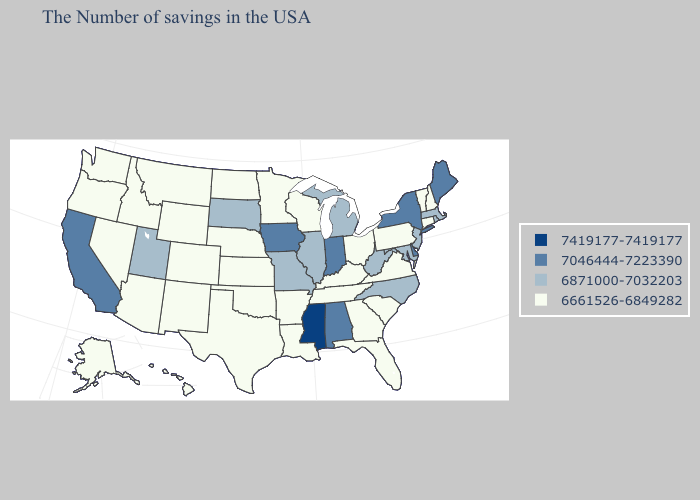What is the highest value in states that border Wyoming?
Be succinct. 6871000-7032203. Among the states that border Rhode Island , does Massachusetts have the lowest value?
Answer briefly. No. Name the states that have a value in the range 6661526-6849282?
Be succinct. New Hampshire, Vermont, Connecticut, Pennsylvania, Virginia, South Carolina, Ohio, Florida, Georgia, Kentucky, Tennessee, Wisconsin, Louisiana, Arkansas, Minnesota, Kansas, Nebraska, Oklahoma, Texas, North Dakota, Wyoming, Colorado, New Mexico, Montana, Arizona, Idaho, Nevada, Washington, Oregon, Alaska, Hawaii. Name the states that have a value in the range 6661526-6849282?
Keep it brief. New Hampshire, Vermont, Connecticut, Pennsylvania, Virginia, South Carolina, Ohio, Florida, Georgia, Kentucky, Tennessee, Wisconsin, Louisiana, Arkansas, Minnesota, Kansas, Nebraska, Oklahoma, Texas, North Dakota, Wyoming, Colorado, New Mexico, Montana, Arizona, Idaho, Nevada, Washington, Oregon, Alaska, Hawaii. What is the highest value in the Northeast ?
Write a very short answer. 7046444-7223390. What is the value of North Carolina?
Write a very short answer. 6871000-7032203. What is the value of Alabama?
Keep it brief. 7046444-7223390. Name the states that have a value in the range 6871000-7032203?
Answer briefly. Massachusetts, Rhode Island, New Jersey, Maryland, North Carolina, West Virginia, Michigan, Illinois, Missouri, South Dakota, Utah. Is the legend a continuous bar?
Write a very short answer. No. Name the states that have a value in the range 6661526-6849282?
Quick response, please. New Hampshire, Vermont, Connecticut, Pennsylvania, Virginia, South Carolina, Ohio, Florida, Georgia, Kentucky, Tennessee, Wisconsin, Louisiana, Arkansas, Minnesota, Kansas, Nebraska, Oklahoma, Texas, North Dakota, Wyoming, Colorado, New Mexico, Montana, Arizona, Idaho, Nevada, Washington, Oregon, Alaska, Hawaii. What is the value of Idaho?
Answer briefly. 6661526-6849282. What is the highest value in the Northeast ?
Quick response, please. 7046444-7223390. Which states have the lowest value in the South?
Give a very brief answer. Virginia, South Carolina, Florida, Georgia, Kentucky, Tennessee, Louisiana, Arkansas, Oklahoma, Texas. Does Connecticut have the lowest value in the Northeast?
Write a very short answer. Yes. How many symbols are there in the legend?
Short answer required. 4. 